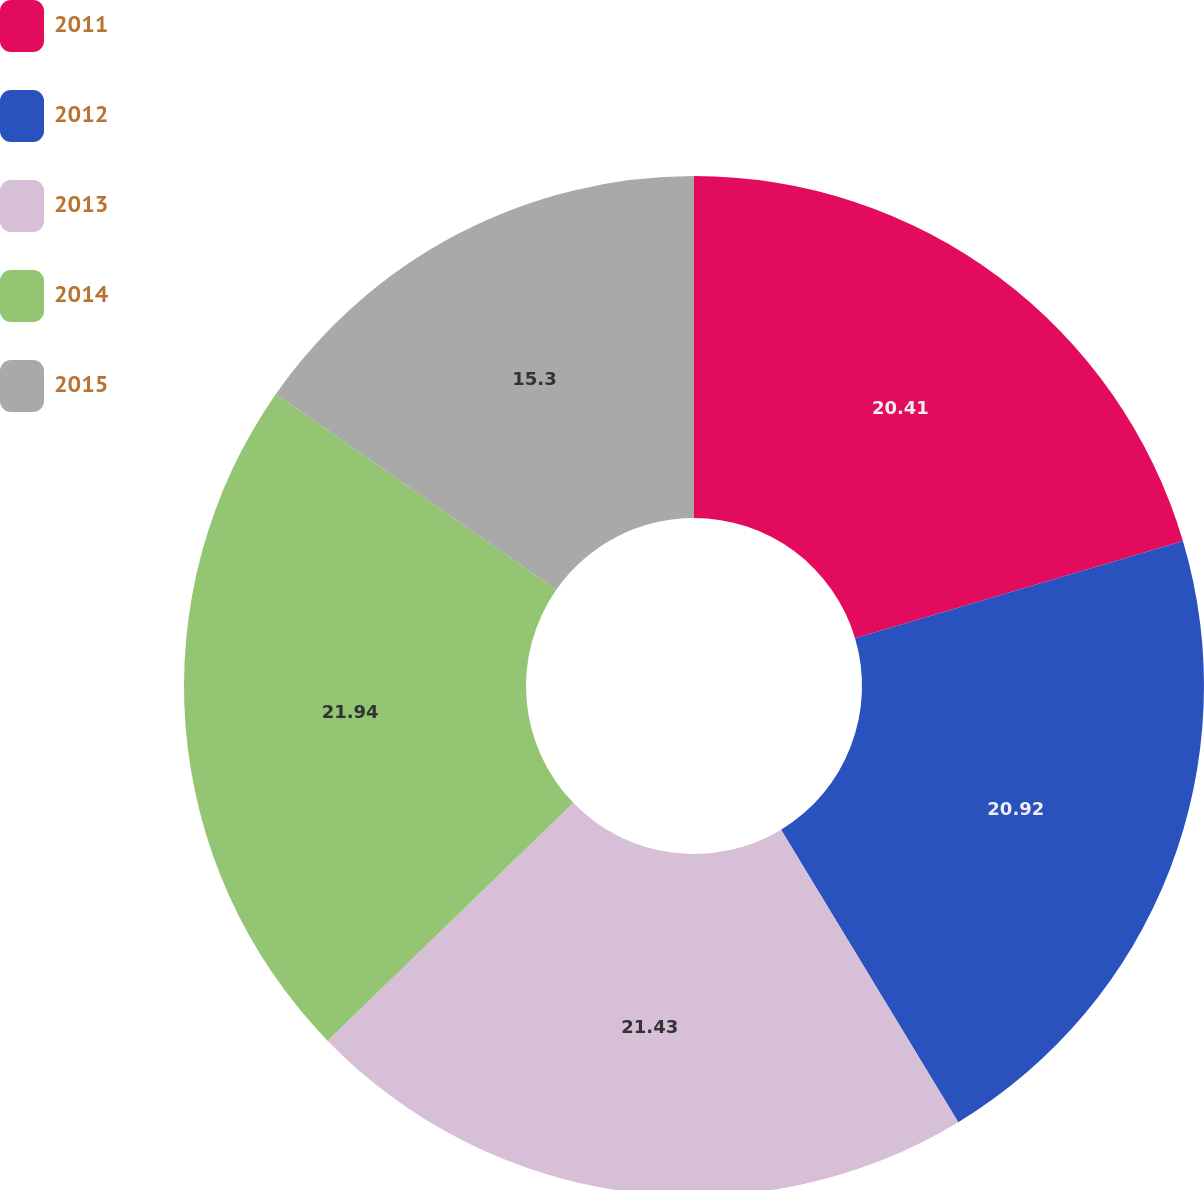Convert chart. <chart><loc_0><loc_0><loc_500><loc_500><pie_chart><fcel>2011<fcel>2012<fcel>2013<fcel>2014<fcel>2015<nl><fcel>20.41%<fcel>20.92%<fcel>21.43%<fcel>21.94%<fcel>15.3%<nl></chart> 